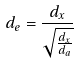<formula> <loc_0><loc_0><loc_500><loc_500>d _ { e } = \frac { d _ { x } } { \sqrt { \frac { d _ { x } } { d _ { a } } } }</formula> 